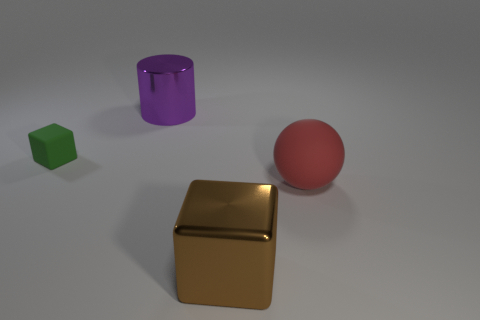How many red things are rubber spheres or small metallic balls?
Your answer should be very brief. 1. What size is the object that is to the left of the shiny thing left of the cube that is in front of the green thing?
Offer a terse response. Small. What size is the green matte thing that is the same shape as the brown metal object?
Your answer should be compact. Small. How many tiny things are either blue rubber cubes or brown objects?
Your answer should be very brief. 0. Do the big thing that is on the right side of the large brown thing and the cube to the right of the purple cylinder have the same material?
Ensure brevity in your answer.  No. What material is the thing in front of the red ball?
Make the answer very short. Metal. How many rubber things are large balls or small yellow cylinders?
Your answer should be compact. 1. There is a shiny object on the left side of the big metallic thing in front of the tiny green rubber block; what color is it?
Provide a short and direct response. Purple. Does the big sphere have the same material as the block on the right side of the large purple object?
Give a very brief answer. No. There is a metallic thing right of the large metal object on the left side of the big shiny thing right of the big metal cylinder; what is its color?
Provide a succinct answer. Brown. 